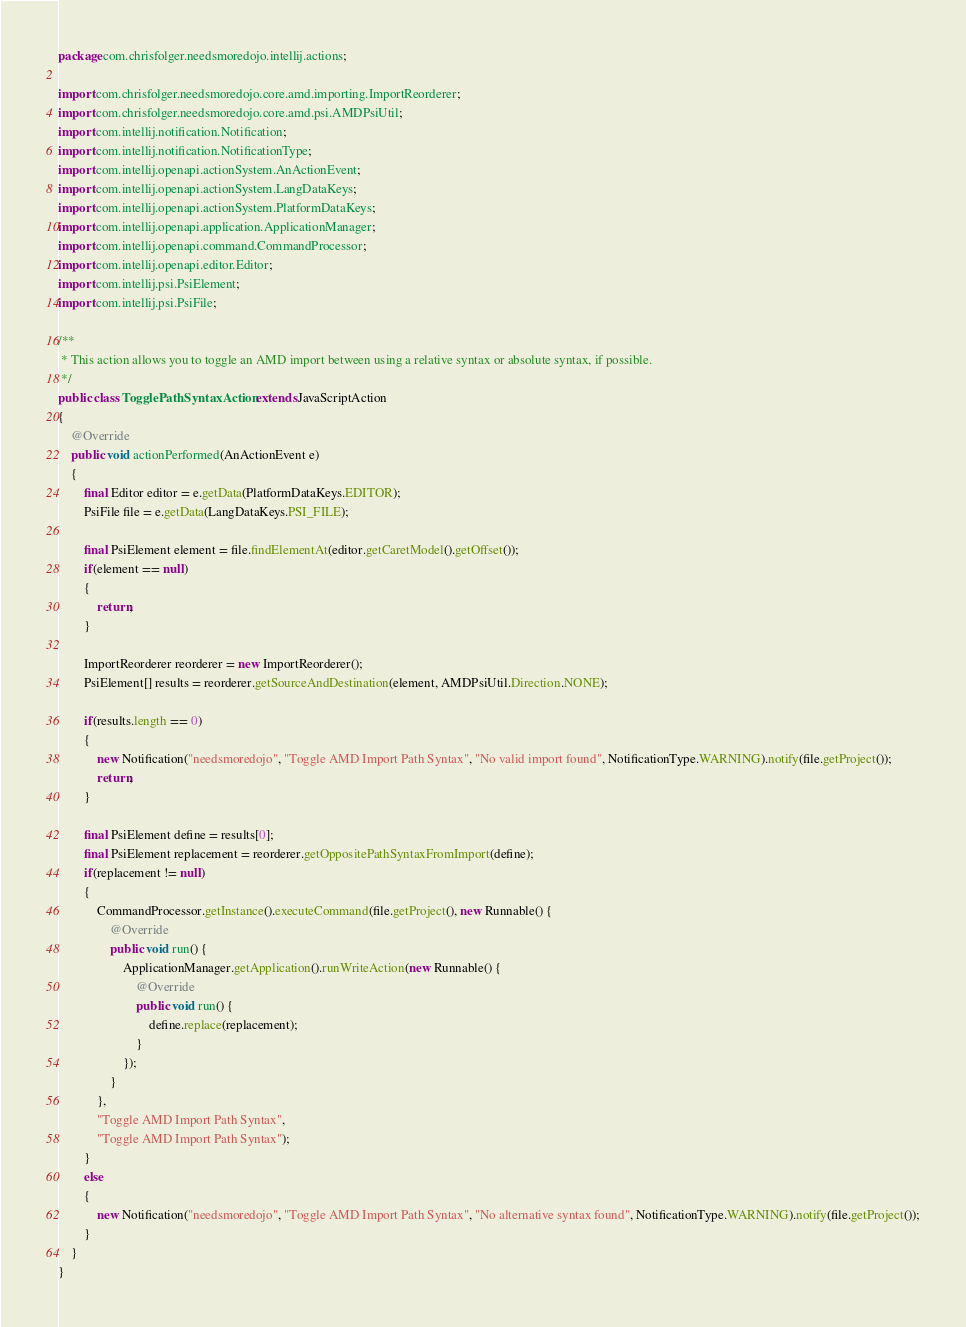Convert code to text. <code><loc_0><loc_0><loc_500><loc_500><_Java_>package com.chrisfolger.needsmoredojo.intellij.actions;

import com.chrisfolger.needsmoredojo.core.amd.importing.ImportReorderer;
import com.chrisfolger.needsmoredojo.core.amd.psi.AMDPsiUtil;
import com.intellij.notification.Notification;
import com.intellij.notification.NotificationType;
import com.intellij.openapi.actionSystem.AnActionEvent;
import com.intellij.openapi.actionSystem.LangDataKeys;
import com.intellij.openapi.actionSystem.PlatformDataKeys;
import com.intellij.openapi.application.ApplicationManager;
import com.intellij.openapi.command.CommandProcessor;
import com.intellij.openapi.editor.Editor;
import com.intellij.psi.PsiElement;
import com.intellij.psi.PsiFile;

/**
 * This action allows you to toggle an AMD import between using a relative syntax or absolute syntax, if possible.
 */
public class TogglePathSyntaxAction extends JavaScriptAction
{
    @Override
    public void actionPerformed(AnActionEvent e)
    {
        final Editor editor = e.getData(PlatformDataKeys.EDITOR);
        PsiFile file = e.getData(LangDataKeys.PSI_FILE);

        final PsiElement element = file.findElementAt(editor.getCaretModel().getOffset());
        if(element == null)
        {
            return;
        }

        ImportReorderer reorderer = new ImportReorderer();
        PsiElement[] results = reorderer.getSourceAndDestination(element, AMDPsiUtil.Direction.NONE);

        if(results.length == 0)
        {
            new Notification("needsmoredojo", "Toggle AMD Import Path Syntax", "No valid import found", NotificationType.WARNING).notify(file.getProject());
            return;
        }

        final PsiElement define = results[0];
        final PsiElement replacement = reorderer.getOppositePathSyntaxFromImport(define);
        if(replacement != null)
        {
            CommandProcessor.getInstance().executeCommand(file.getProject(), new Runnable() {
                @Override
                public void run() {
                    ApplicationManager.getApplication().runWriteAction(new Runnable() {
                        @Override
                        public void run() {
                            define.replace(replacement);
                        }
                    });
                }
            },
            "Toggle AMD Import Path Syntax",
            "Toggle AMD Import Path Syntax");
        }
        else
        {
            new Notification("needsmoredojo", "Toggle AMD Import Path Syntax", "No alternative syntax found", NotificationType.WARNING).notify(file.getProject());
        }
    }
}
</code> 